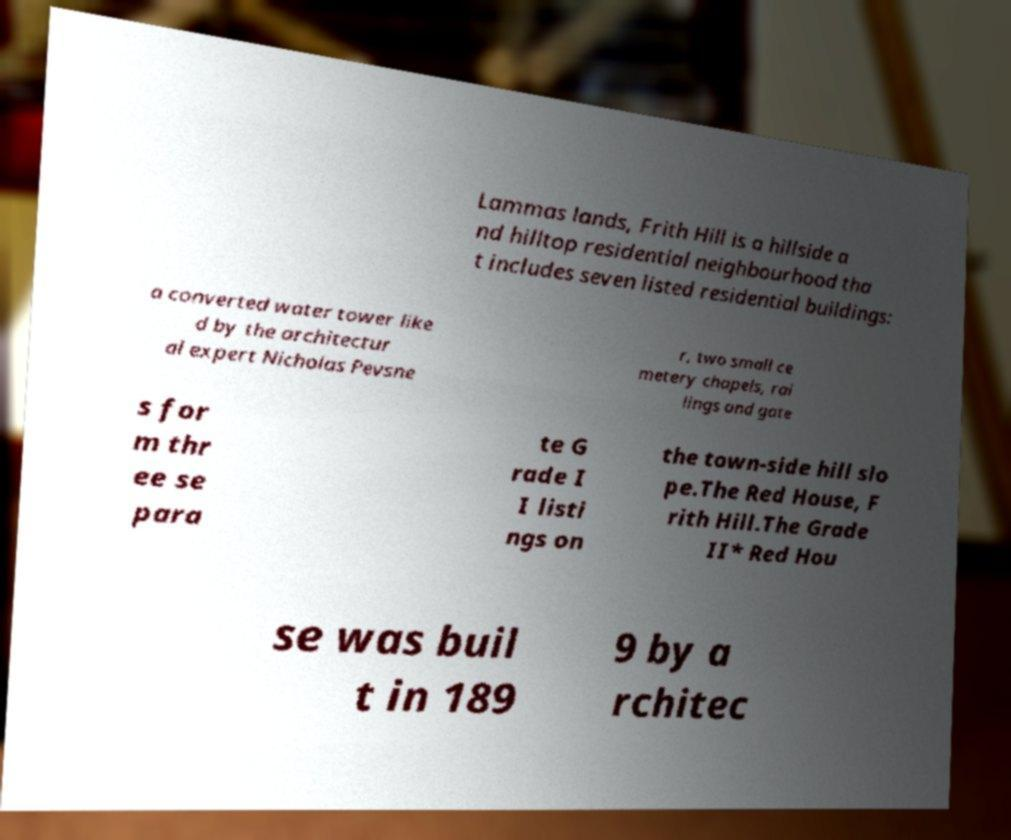Can you read and provide the text displayed in the image?This photo seems to have some interesting text. Can you extract and type it out for me? Lammas lands, Frith Hill is a hillside a nd hilltop residential neighbourhood tha t includes seven listed residential buildings: a converted water tower like d by the architectur al expert Nicholas Pevsne r, two small ce metery chapels, rai lings and gate s for m thr ee se para te G rade I I listi ngs on the town-side hill slo pe.The Red House, F rith Hill.The Grade II* Red Hou se was buil t in 189 9 by a rchitec 